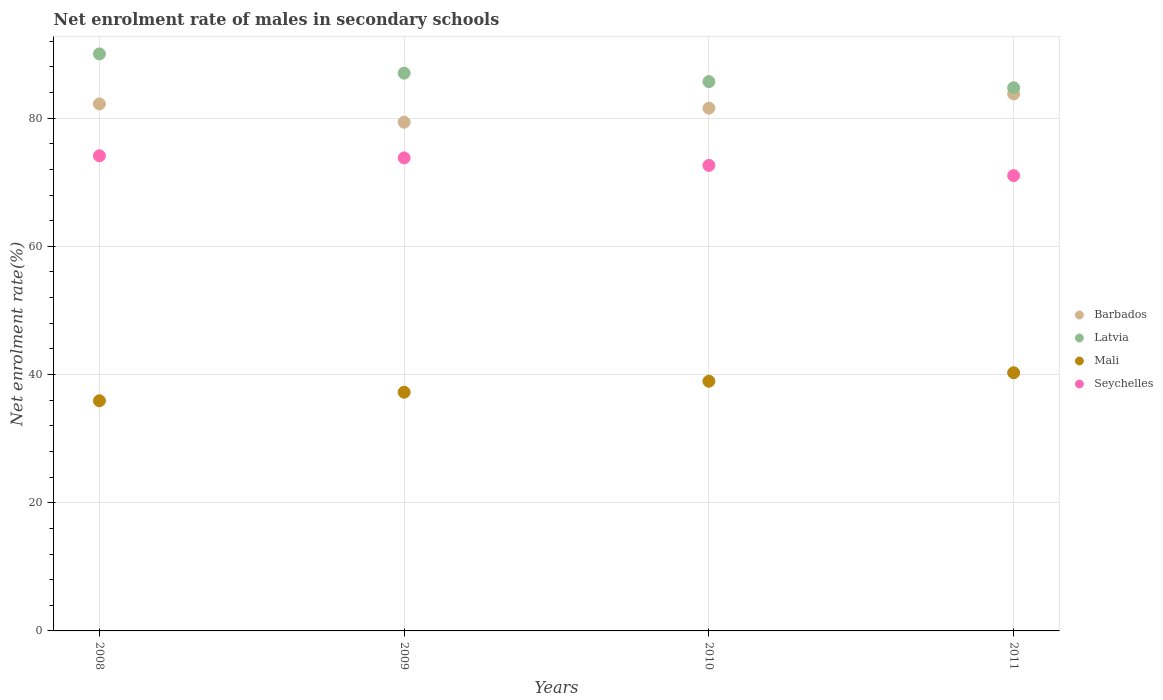How many different coloured dotlines are there?
Make the answer very short. 4. Is the number of dotlines equal to the number of legend labels?
Provide a succinct answer. Yes. What is the net enrolment rate of males in secondary schools in Seychelles in 2011?
Your answer should be compact. 71.03. Across all years, what is the maximum net enrolment rate of males in secondary schools in Barbados?
Offer a very short reply. 83.78. Across all years, what is the minimum net enrolment rate of males in secondary schools in Barbados?
Your answer should be very brief. 79.36. In which year was the net enrolment rate of males in secondary schools in Seychelles maximum?
Ensure brevity in your answer.  2008. What is the total net enrolment rate of males in secondary schools in Latvia in the graph?
Provide a succinct answer. 347.49. What is the difference between the net enrolment rate of males in secondary schools in Seychelles in 2008 and that in 2010?
Your response must be concise. 1.5. What is the difference between the net enrolment rate of males in secondary schools in Barbados in 2008 and the net enrolment rate of males in secondary schools in Latvia in 2009?
Your answer should be compact. -4.8. What is the average net enrolment rate of males in secondary schools in Mali per year?
Make the answer very short. 38.09. In the year 2008, what is the difference between the net enrolment rate of males in secondary schools in Latvia and net enrolment rate of males in secondary schools in Mali?
Offer a terse response. 54.12. What is the ratio of the net enrolment rate of males in secondary schools in Mali in 2010 to that in 2011?
Offer a terse response. 0.97. Is the net enrolment rate of males in secondary schools in Mali in 2008 less than that in 2011?
Offer a terse response. Yes. Is the difference between the net enrolment rate of males in secondary schools in Latvia in 2008 and 2009 greater than the difference between the net enrolment rate of males in secondary schools in Mali in 2008 and 2009?
Your answer should be very brief. Yes. What is the difference between the highest and the second highest net enrolment rate of males in secondary schools in Latvia?
Make the answer very short. 3. What is the difference between the highest and the lowest net enrolment rate of males in secondary schools in Barbados?
Provide a short and direct response. 4.41. In how many years, is the net enrolment rate of males in secondary schools in Latvia greater than the average net enrolment rate of males in secondary schools in Latvia taken over all years?
Keep it short and to the point. 2. Is the sum of the net enrolment rate of males in secondary schools in Latvia in 2008 and 2009 greater than the maximum net enrolment rate of males in secondary schools in Mali across all years?
Offer a very short reply. Yes. Is it the case that in every year, the sum of the net enrolment rate of males in secondary schools in Mali and net enrolment rate of males in secondary schools in Barbados  is greater than the sum of net enrolment rate of males in secondary schools in Seychelles and net enrolment rate of males in secondary schools in Latvia?
Ensure brevity in your answer.  Yes. Is it the case that in every year, the sum of the net enrolment rate of males in secondary schools in Latvia and net enrolment rate of males in secondary schools in Barbados  is greater than the net enrolment rate of males in secondary schools in Seychelles?
Your answer should be very brief. Yes. Does the net enrolment rate of males in secondary schools in Barbados monotonically increase over the years?
Keep it short and to the point. No. Is the net enrolment rate of males in secondary schools in Seychelles strictly greater than the net enrolment rate of males in secondary schools in Barbados over the years?
Provide a short and direct response. No. How many dotlines are there?
Your response must be concise. 4. How many years are there in the graph?
Your answer should be very brief. 4. Are the values on the major ticks of Y-axis written in scientific E-notation?
Ensure brevity in your answer.  No. Does the graph contain any zero values?
Ensure brevity in your answer.  No. Does the graph contain grids?
Offer a terse response. Yes. Where does the legend appear in the graph?
Provide a succinct answer. Center right. What is the title of the graph?
Keep it short and to the point. Net enrolment rate of males in secondary schools. What is the label or title of the X-axis?
Your answer should be compact. Years. What is the label or title of the Y-axis?
Offer a terse response. Net enrolment rate(%). What is the Net enrolment rate(%) in Barbados in 2008?
Provide a short and direct response. 82.22. What is the Net enrolment rate(%) in Latvia in 2008?
Offer a very short reply. 90.02. What is the Net enrolment rate(%) of Mali in 2008?
Make the answer very short. 35.91. What is the Net enrolment rate(%) in Seychelles in 2008?
Offer a very short reply. 74.13. What is the Net enrolment rate(%) of Barbados in 2009?
Offer a terse response. 79.36. What is the Net enrolment rate(%) in Latvia in 2009?
Your response must be concise. 87.02. What is the Net enrolment rate(%) of Mali in 2009?
Make the answer very short. 37.24. What is the Net enrolment rate(%) of Seychelles in 2009?
Ensure brevity in your answer.  73.8. What is the Net enrolment rate(%) in Barbados in 2010?
Give a very brief answer. 81.56. What is the Net enrolment rate(%) of Latvia in 2010?
Your response must be concise. 85.7. What is the Net enrolment rate(%) in Mali in 2010?
Offer a terse response. 38.95. What is the Net enrolment rate(%) of Seychelles in 2010?
Make the answer very short. 72.63. What is the Net enrolment rate(%) in Barbados in 2011?
Give a very brief answer. 83.78. What is the Net enrolment rate(%) of Latvia in 2011?
Your response must be concise. 84.74. What is the Net enrolment rate(%) of Mali in 2011?
Your answer should be compact. 40.28. What is the Net enrolment rate(%) in Seychelles in 2011?
Offer a terse response. 71.03. Across all years, what is the maximum Net enrolment rate(%) of Barbados?
Your answer should be very brief. 83.78. Across all years, what is the maximum Net enrolment rate(%) of Latvia?
Your response must be concise. 90.02. Across all years, what is the maximum Net enrolment rate(%) in Mali?
Ensure brevity in your answer.  40.28. Across all years, what is the maximum Net enrolment rate(%) of Seychelles?
Your response must be concise. 74.13. Across all years, what is the minimum Net enrolment rate(%) of Barbados?
Make the answer very short. 79.36. Across all years, what is the minimum Net enrolment rate(%) in Latvia?
Give a very brief answer. 84.74. Across all years, what is the minimum Net enrolment rate(%) in Mali?
Your answer should be compact. 35.91. Across all years, what is the minimum Net enrolment rate(%) in Seychelles?
Your answer should be compact. 71.03. What is the total Net enrolment rate(%) of Barbados in the graph?
Offer a terse response. 326.92. What is the total Net enrolment rate(%) of Latvia in the graph?
Make the answer very short. 347.49. What is the total Net enrolment rate(%) in Mali in the graph?
Provide a succinct answer. 152.38. What is the total Net enrolment rate(%) of Seychelles in the graph?
Provide a succinct answer. 291.59. What is the difference between the Net enrolment rate(%) of Barbados in 2008 and that in 2009?
Provide a succinct answer. 2.86. What is the difference between the Net enrolment rate(%) in Latvia in 2008 and that in 2009?
Your answer should be very brief. 3. What is the difference between the Net enrolment rate(%) in Mali in 2008 and that in 2009?
Provide a short and direct response. -1.33. What is the difference between the Net enrolment rate(%) of Seychelles in 2008 and that in 2009?
Your answer should be compact. 0.33. What is the difference between the Net enrolment rate(%) in Barbados in 2008 and that in 2010?
Provide a short and direct response. 0.66. What is the difference between the Net enrolment rate(%) in Latvia in 2008 and that in 2010?
Offer a very short reply. 4.32. What is the difference between the Net enrolment rate(%) in Mali in 2008 and that in 2010?
Your answer should be compact. -3.04. What is the difference between the Net enrolment rate(%) of Seychelles in 2008 and that in 2010?
Provide a succinct answer. 1.5. What is the difference between the Net enrolment rate(%) in Barbados in 2008 and that in 2011?
Give a very brief answer. -1.56. What is the difference between the Net enrolment rate(%) in Latvia in 2008 and that in 2011?
Offer a very short reply. 5.28. What is the difference between the Net enrolment rate(%) of Mali in 2008 and that in 2011?
Provide a short and direct response. -4.37. What is the difference between the Net enrolment rate(%) of Seychelles in 2008 and that in 2011?
Your response must be concise. 3.1. What is the difference between the Net enrolment rate(%) in Barbados in 2009 and that in 2010?
Provide a succinct answer. -2.19. What is the difference between the Net enrolment rate(%) in Latvia in 2009 and that in 2010?
Keep it short and to the point. 1.32. What is the difference between the Net enrolment rate(%) of Mali in 2009 and that in 2010?
Give a very brief answer. -1.71. What is the difference between the Net enrolment rate(%) in Seychelles in 2009 and that in 2010?
Make the answer very short. 1.17. What is the difference between the Net enrolment rate(%) of Barbados in 2009 and that in 2011?
Offer a very short reply. -4.41. What is the difference between the Net enrolment rate(%) of Latvia in 2009 and that in 2011?
Keep it short and to the point. 2.28. What is the difference between the Net enrolment rate(%) of Mali in 2009 and that in 2011?
Provide a short and direct response. -3.04. What is the difference between the Net enrolment rate(%) in Seychelles in 2009 and that in 2011?
Make the answer very short. 2.77. What is the difference between the Net enrolment rate(%) of Barbados in 2010 and that in 2011?
Ensure brevity in your answer.  -2.22. What is the difference between the Net enrolment rate(%) of Latvia in 2010 and that in 2011?
Your answer should be very brief. 0.96. What is the difference between the Net enrolment rate(%) in Mali in 2010 and that in 2011?
Give a very brief answer. -1.33. What is the difference between the Net enrolment rate(%) of Seychelles in 2010 and that in 2011?
Keep it short and to the point. 1.6. What is the difference between the Net enrolment rate(%) in Barbados in 2008 and the Net enrolment rate(%) in Latvia in 2009?
Your answer should be compact. -4.8. What is the difference between the Net enrolment rate(%) in Barbados in 2008 and the Net enrolment rate(%) in Mali in 2009?
Your answer should be compact. 44.98. What is the difference between the Net enrolment rate(%) in Barbados in 2008 and the Net enrolment rate(%) in Seychelles in 2009?
Give a very brief answer. 8.42. What is the difference between the Net enrolment rate(%) of Latvia in 2008 and the Net enrolment rate(%) of Mali in 2009?
Provide a short and direct response. 52.78. What is the difference between the Net enrolment rate(%) in Latvia in 2008 and the Net enrolment rate(%) in Seychelles in 2009?
Make the answer very short. 16.22. What is the difference between the Net enrolment rate(%) in Mali in 2008 and the Net enrolment rate(%) in Seychelles in 2009?
Offer a terse response. -37.89. What is the difference between the Net enrolment rate(%) of Barbados in 2008 and the Net enrolment rate(%) of Latvia in 2010?
Offer a terse response. -3.48. What is the difference between the Net enrolment rate(%) in Barbados in 2008 and the Net enrolment rate(%) in Mali in 2010?
Offer a terse response. 43.27. What is the difference between the Net enrolment rate(%) in Barbados in 2008 and the Net enrolment rate(%) in Seychelles in 2010?
Your answer should be compact. 9.59. What is the difference between the Net enrolment rate(%) in Latvia in 2008 and the Net enrolment rate(%) in Mali in 2010?
Give a very brief answer. 51.07. What is the difference between the Net enrolment rate(%) in Latvia in 2008 and the Net enrolment rate(%) in Seychelles in 2010?
Your answer should be very brief. 17.39. What is the difference between the Net enrolment rate(%) in Mali in 2008 and the Net enrolment rate(%) in Seychelles in 2010?
Your response must be concise. -36.72. What is the difference between the Net enrolment rate(%) of Barbados in 2008 and the Net enrolment rate(%) of Latvia in 2011?
Ensure brevity in your answer.  -2.52. What is the difference between the Net enrolment rate(%) of Barbados in 2008 and the Net enrolment rate(%) of Mali in 2011?
Provide a short and direct response. 41.94. What is the difference between the Net enrolment rate(%) of Barbados in 2008 and the Net enrolment rate(%) of Seychelles in 2011?
Ensure brevity in your answer.  11.19. What is the difference between the Net enrolment rate(%) in Latvia in 2008 and the Net enrolment rate(%) in Mali in 2011?
Provide a succinct answer. 49.74. What is the difference between the Net enrolment rate(%) of Latvia in 2008 and the Net enrolment rate(%) of Seychelles in 2011?
Your answer should be compact. 18.99. What is the difference between the Net enrolment rate(%) of Mali in 2008 and the Net enrolment rate(%) of Seychelles in 2011?
Provide a succinct answer. -35.13. What is the difference between the Net enrolment rate(%) in Barbados in 2009 and the Net enrolment rate(%) in Latvia in 2010?
Ensure brevity in your answer.  -6.34. What is the difference between the Net enrolment rate(%) of Barbados in 2009 and the Net enrolment rate(%) of Mali in 2010?
Your response must be concise. 40.41. What is the difference between the Net enrolment rate(%) in Barbados in 2009 and the Net enrolment rate(%) in Seychelles in 2010?
Your response must be concise. 6.73. What is the difference between the Net enrolment rate(%) in Latvia in 2009 and the Net enrolment rate(%) in Mali in 2010?
Ensure brevity in your answer.  48.07. What is the difference between the Net enrolment rate(%) of Latvia in 2009 and the Net enrolment rate(%) of Seychelles in 2010?
Offer a terse response. 14.39. What is the difference between the Net enrolment rate(%) of Mali in 2009 and the Net enrolment rate(%) of Seychelles in 2010?
Give a very brief answer. -35.39. What is the difference between the Net enrolment rate(%) in Barbados in 2009 and the Net enrolment rate(%) in Latvia in 2011?
Provide a succinct answer. -5.38. What is the difference between the Net enrolment rate(%) of Barbados in 2009 and the Net enrolment rate(%) of Mali in 2011?
Your response must be concise. 39.08. What is the difference between the Net enrolment rate(%) in Barbados in 2009 and the Net enrolment rate(%) in Seychelles in 2011?
Your response must be concise. 8.33. What is the difference between the Net enrolment rate(%) of Latvia in 2009 and the Net enrolment rate(%) of Mali in 2011?
Your response must be concise. 46.74. What is the difference between the Net enrolment rate(%) in Latvia in 2009 and the Net enrolment rate(%) in Seychelles in 2011?
Offer a terse response. 15.99. What is the difference between the Net enrolment rate(%) of Mali in 2009 and the Net enrolment rate(%) of Seychelles in 2011?
Your answer should be compact. -33.8. What is the difference between the Net enrolment rate(%) of Barbados in 2010 and the Net enrolment rate(%) of Latvia in 2011?
Provide a succinct answer. -3.19. What is the difference between the Net enrolment rate(%) in Barbados in 2010 and the Net enrolment rate(%) in Mali in 2011?
Your answer should be very brief. 41.28. What is the difference between the Net enrolment rate(%) of Barbados in 2010 and the Net enrolment rate(%) of Seychelles in 2011?
Provide a short and direct response. 10.52. What is the difference between the Net enrolment rate(%) of Latvia in 2010 and the Net enrolment rate(%) of Mali in 2011?
Make the answer very short. 45.42. What is the difference between the Net enrolment rate(%) of Latvia in 2010 and the Net enrolment rate(%) of Seychelles in 2011?
Provide a short and direct response. 14.67. What is the difference between the Net enrolment rate(%) of Mali in 2010 and the Net enrolment rate(%) of Seychelles in 2011?
Offer a terse response. -32.08. What is the average Net enrolment rate(%) in Barbados per year?
Offer a terse response. 81.73. What is the average Net enrolment rate(%) in Latvia per year?
Ensure brevity in your answer.  86.87. What is the average Net enrolment rate(%) in Mali per year?
Your answer should be compact. 38.09. What is the average Net enrolment rate(%) in Seychelles per year?
Keep it short and to the point. 72.9. In the year 2008, what is the difference between the Net enrolment rate(%) in Barbados and Net enrolment rate(%) in Latvia?
Your answer should be very brief. -7.8. In the year 2008, what is the difference between the Net enrolment rate(%) in Barbados and Net enrolment rate(%) in Mali?
Ensure brevity in your answer.  46.31. In the year 2008, what is the difference between the Net enrolment rate(%) in Barbados and Net enrolment rate(%) in Seychelles?
Your answer should be compact. 8.09. In the year 2008, what is the difference between the Net enrolment rate(%) of Latvia and Net enrolment rate(%) of Mali?
Offer a terse response. 54.12. In the year 2008, what is the difference between the Net enrolment rate(%) in Latvia and Net enrolment rate(%) in Seychelles?
Your response must be concise. 15.89. In the year 2008, what is the difference between the Net enrolment rate(%) of Mali and Net enrolment rate(%) of Seychelles?
Give a very brief answer. -38.22. In the year 2009, what is the difference between the Net enrolment rate(%) of Barbados and Net enrolment rate(%) of Latvia?
Make the answer very short. -7.66. In the year 2009, what is the difference between the Net enrolment rate(%) of Barbados and Net enrolment rate(%) of Mali?
Ensure brevity in your answer.  42.13. In the year 2009, what is the difference between the Net enrolment rate(%) in Barbados and Net enrolment rate(%) in Seychelles?
Provide a succinct answer. 5.57. In the year 2009, what is the difference between the Net enrolment rate(%) of Latvia and Net enrolment rate(%) of Mali?
Offer a terse response. 49.78. In the year 2009, what is the difference between the Net enrolment rate(%) in Latvia and Net enrolment rate(%) in Seychelles?
Your answer should be compact. 13.22. In the year 2009, what is the difference between the Net enrolment rate(%) of Mali and Net enrolment rate(%) of Seychelles?
Offer a terse response. -36.56. In the year 2010, what is the difference between the Net enrolment rate(%) in Barbados and Net enrolment rate(%) in Latvia?
Keep it short and to the point. -4.15. In the year 2010, what is the difference between the Net enrolment rate(%) of Barbados and Net enrolment rate(%) of Mali?
Your answer should be very brief. 42.6. In the year 2010, what is the difference between the Net enrolment rate(%) of Barbados and Net enrolment rate(%) of Seychelles?
Your answer should be compact. 8.92. In the year 2010, what is the difference between the Net enrolment rate(%) in Latvia and Net enrolment rate(%) in Mali?
Offer a very short reply. 46.75. In the year 2010, what is the difference between the Net enrolment rate(%) in Latvia and Net enrolment rate(%) in Seychelles?
Your answer should be very brief. 13.07. In the year 2010, what is the difference between the Net enrolment rate(%) of Mali and Net enrolment rate(%) of Seychelles?
Your answer should be very brief. -33.68. In the year 2011, what is the difference between the Net enrolment rate(%) of Barbados and Net enrolment rate(%) of Latvia?
Ensure brevity in your answer.  -0.97. In the year 2011, what is the difference between the Net enrolment rate(%) in Barbados and Net enrolment rate(%) in Mali?
Provide a short and direct response. 43.5. In the year 2011, what is the difference between the Net enrolment rate(%) in Barbados and Net enrolment rate(%) in Seychelles?
Provide a short and direct response. 12.75. In the year 2011, what is the difference between the Net enrolment rate(%) of Latvia and Net enrolment rate(%) of Mali?
Ensure brevity in your answer.  44.46. In the year 2011, what is the difference between the Net enrolment rate(%) in Latvia and Net enrolment rate(%) in Seychelles?
Keep it short and to the point. 13.71. In the year 2011, what is the difference between the Net enrolment rate(%) of Mali and Net enrolment rate(%) of Seychelles?
Provide a succinct answer. -30.75. What is the ratio of the Net enrolment rate(%) in Barbados in 2008 to that in 2009?
Offer a very short reply. 1.04. What is the ratio of the Net enrolment rate(%) of Latvia in 2008 to that in 2009?
Provide a short and direct response. 1.03. What is the ratio of the Net enrolment rate(%) in Barbados in 2008 to that in 2010?
Offer a terse response. 1.01. What is the ratio of the Net enrolment rate(%) of Latvia in 2008 to that in 2010?
Ensure brevity in your answer.  1.05. What is the ratio of the Net enrolment rate(%) in Mali in 2008 to that in 2010?
Ensure brevity in your answer.  0.92. What is the ratio of the Net enrolment rate(%) in Seychelles in 2008 to that in 2010?
Provide a succinct answer. 1.02. What is the ratio of the Net enrolment rate(%) of Barbados in 2008 to that in 2011?
Your answer should be compact. 0.98. What is the ratio of the Net enrolment rate(%) of Latvia in 2008 to that in 2011?
Offer a terse response. 1.06. What is the ratio of the Net enrolment rate(%) in Mali in 2008 to that in 2011?
Give a very brief answer. 0.89. What is the ratio of the Net enrolment rate(%) in Seychelles in 2008 to that in 2011?
Your response must be concise. 1.04. What is the ratio of the Net enrolment rate(%) of Barbados in 2009 to that in 2010?
Make the answer very short. 0.97. What is the ratio of the Net enrolment rate(%) of Latvia in 2009 to that in 2010?
Your answer should be very brief. 1.02. What is the ratio of the Net enrolment rate(%) in Mali in 2009 to that in 2010?
Make the answer very short. 0.96. What is the ratio of the Net enrolment rate(%) in Seychelles in 2009 to that in 2010?
Provide a succinct answer. 1.02. What is the ratio of the Net enrolment rate(%) of Barbados in 2009 to that in 2011?
Keep it short and to the point. 0.95. What is the ratio of the Net enrolment rate(%) of Latvia in 2009 to that in 2011?
Offer a terse response. 1.03. What is the ratio of the Net enrolment rate(%) of Mali in 2009 to that in 2011?
Your answer should be very brief. 0.92. What is the ratio of the Net enrolment rate(%) of Seychelles in 2009 to that in 2011?
Your answer should be very brief. 1.04. What is the ratio of the Net enrolment rate(%) in Barbados in 2010 to that in 2011?
Your answer should be compact. 0.97. What is the ratio of the Net enrolment rate(%) of Latvia in 2010 to that in 2011?
Make the answer very short. 1.01. What is the ratio of the Net enrolment rate(%) of Mali in 2010 to that in 2011?
Provide a succinct answer. 0.97. What is the ratio of the Net enrolment rate(%) in Seychelles in 2010 to that in 2011?
Your response must be concise. 1.02. What is the difference between the highest and the second highest Net enrolment rate(%) in Barbados?
Offer a very short reply. 1.56. What is the difference between the highest and the second highest Net enrolment rate(%) of Latvia?
Ensure brevity in your answer.  3. What is the difference between the highest and the second highest Net enrolment rate(%) of Mali?
Provide a succinct answer. 1.33. What is the difference between the highest and the second highest Net enrolment rate(%) in Seychelles?
Make the answer very short. 0.33. What is the difference between the highest and the lowest Net enrolment rate(%) of Barbados?
Make the answer very short. 4.41. What is the difference between the highest and the lowest Net enrolment rate(%) in Latvia?
Offer a very short reply. 5.28. What is the difference between the highest and the lowest Net enrolment rate(%) in Mali?
Ensure brevity in your answer.  4.37. What is the difference between the highest and the lowest Net enrolment rate(%) in Seychelles?
Your answer should be compact. 3.1. 